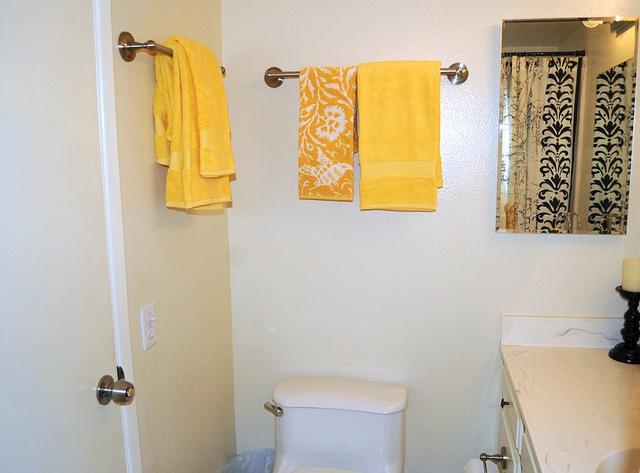What color are the towels?
Concise answer only. Yellow. Is the bathroom clean?
Answer briefly. Yes. Is there a candle?
Keep it brief. Yes. 